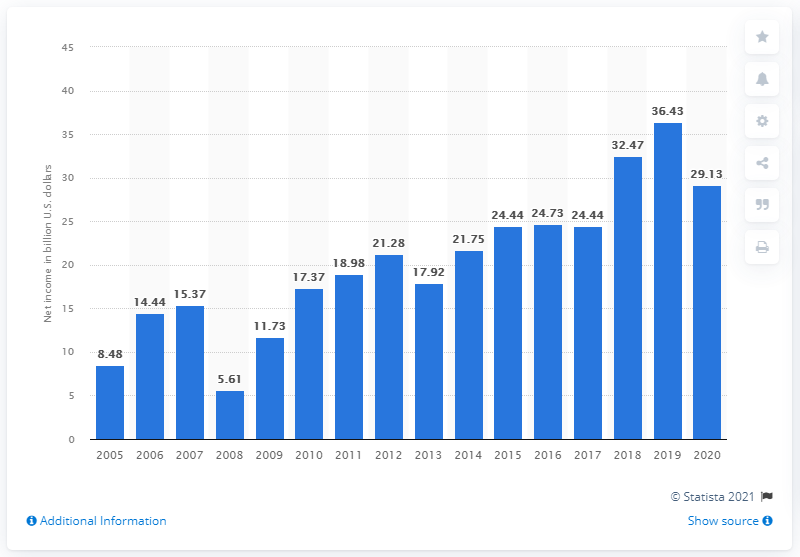Highlight a few significant elements in this photo. JPMorgan Chase's net income in dollars in 2020 was 29.13. In 2019, JPMorgan Chase's net income was valued at 36.43 billion dollars. 